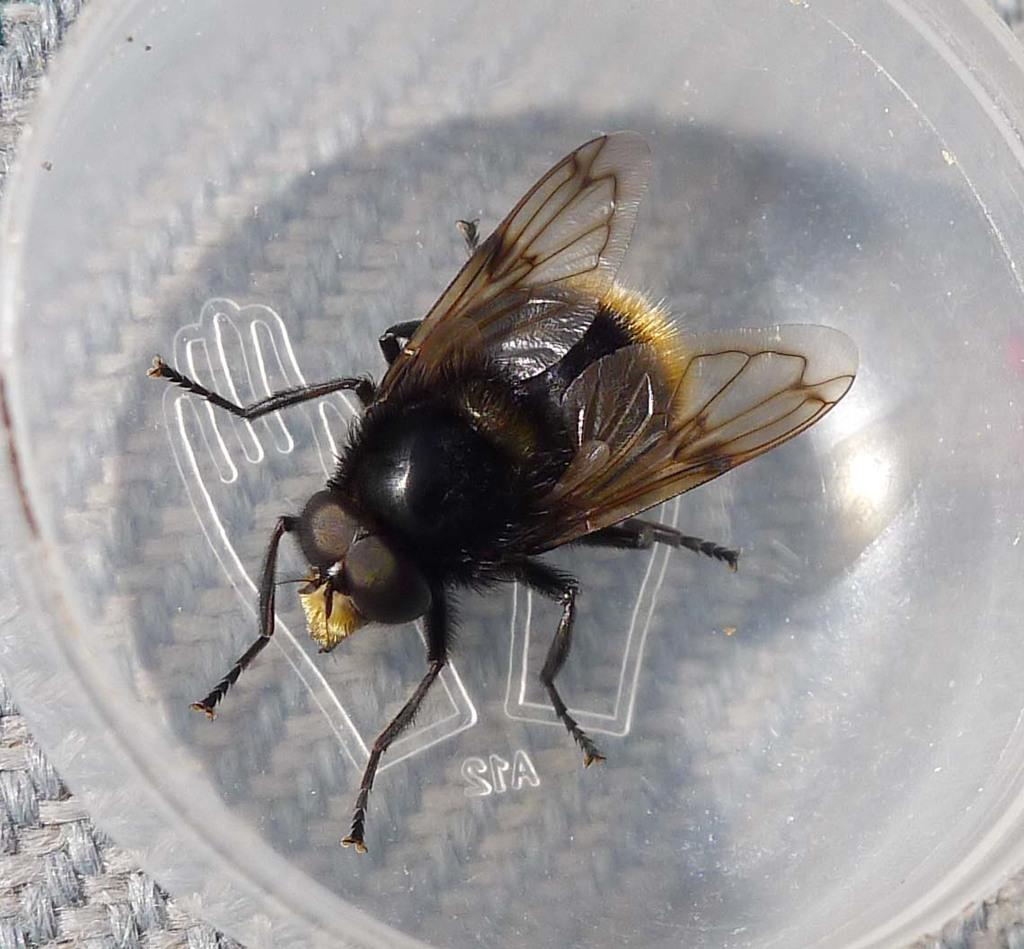What type of insect is in the image? There is a house fly in the image. What are the main features of the house fly? The house fly has wings and a head. What is the color of the house fly? The house fly is brown in color. Where is the house fly located in the image? The house fly is in a bowl. What type of tank can be seen in the image? There is no tank present in the image; it features a house fly in a bowl. 